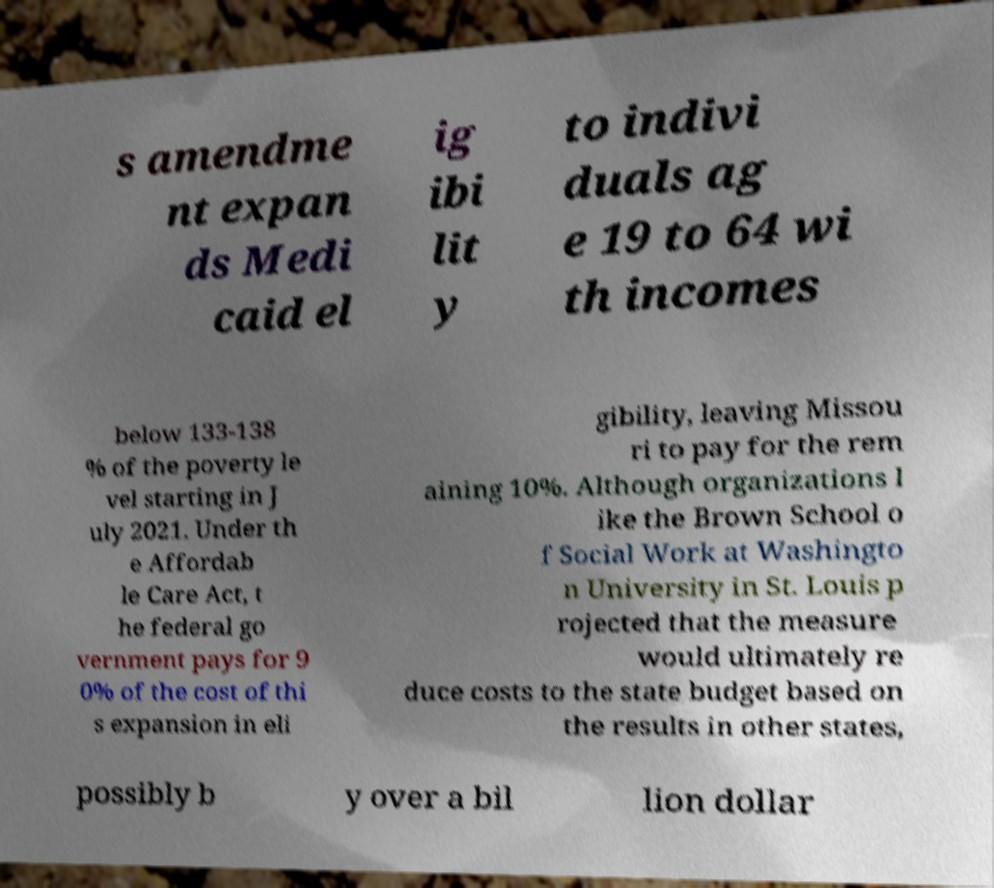Please read and relay the text visible in this image. What does it say? s amendme nt expan ds Medi caid el ig ibi lit y to indivi duals ag e 19 to 64 wi th incomes below 133-138 % of the poverty le vel starting in J uly 2021. Under th e Affordab le Care Act, t he federal go vernment pays for 9 0% of the cost of thi s expansion in eli gibility, leaving Missou ri to pay for the rem aining 10%. Although organizations l ike the Brown School o f Social Work at Washingto n University in St. Louis p rojected that the measure would ultimately re duce costs to the state budget based on the results in other states, possibly b y over a bil lion dollar 